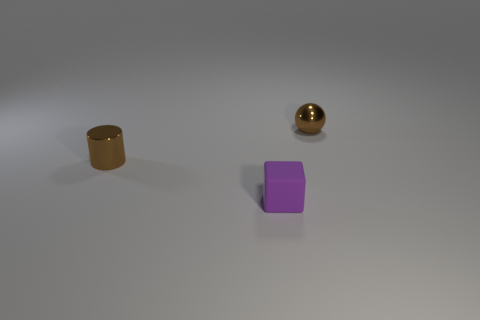There is a object that is the same color as the small sphere; what is its shape?
Provide a short and direct response. Cylinder. There is a thing that is both on the left side of the metal ball and behind the tiny rubber object; what is its shape?
Provide a succinct answer. Cylinder. Is the number of tiny brown metallic spheres left of the brown cylinder the same as the number of small cylinders?
Your response must be concise. No. What number of things are either metallic things or purple rubber cubes left of the brown metal ball?
Ensure brevity in your answer.  3. Are there any other tiny purple objects that have the same shape as the purple object?
Your answer should be very brief. No. Are there the same number of small purple cubes on the left side of the small block and small brown balls that are in front of the brown sphere?
Ensure brevity in your answer.  Yes. Is there any other thing that is the same size as the matte thing?
Keep it short and to the point. Yes. How many purple things are either big rubber objects or tiny rubber cubes?
Offer a terse response. 1. What number of purple cubes have the same size as the brown ball?
Provide a short and direct response. 1. What color is the tiny thing that is on the right side of the metal cylinder and behind the tiny matte thing?
Keep it short and to the point. Brown. 